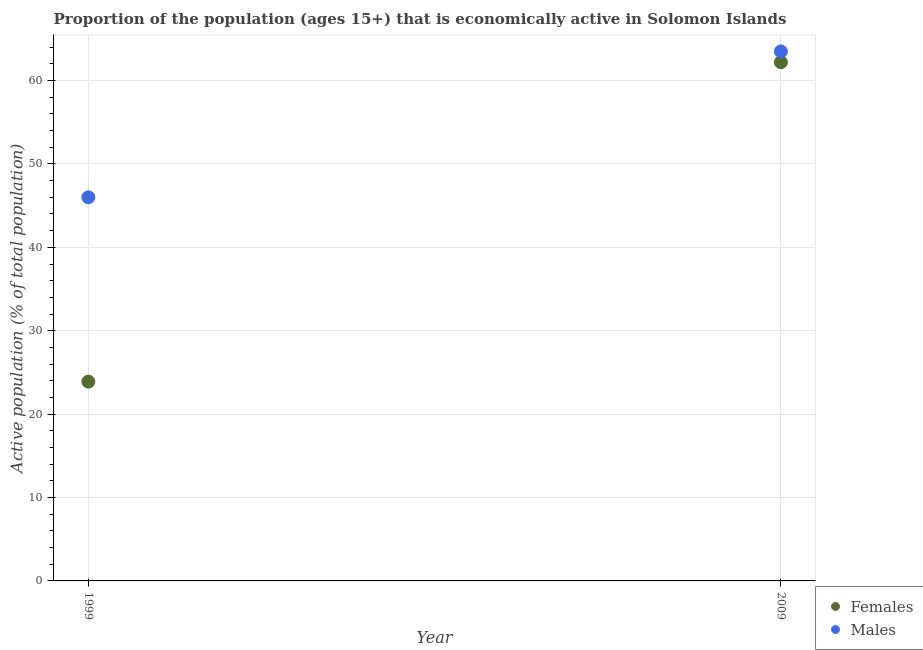What is the percentage of economically active female population in 1999?
Keep it short and to the point. 23.9. Across all years, what is the maximum percentage of economically active male population?
Your answer should be very brief. 63.5. In which year was the percentage of economically active female population maximum?
Make the answer very short. 2009. In which year was the percentage of economically active male population minimum?
Give a very brief answer. 1999. What is the total percentage of economically active male population in the graph?
Your response must be concise. 109.5. What is the difference between the percentage of economically active male population in 1999 and that in 2009?
Your answer should be compact. -17.5. What is the difference between the percentage of economically active female population in 1999 and the percentage of economically active male population in 2009?
Provide a short and direct response. -39.6. What is the average percentage of economically active male population per year?
Provide a succinct answer. 54.75. In the year 1999, what is the difference between the percentage of economically active male population and percentage of economically active female population?
Keep it short and to the point. 22.1. In how many years, is the percentage of economically active male population greater than 22 %?
Offer a terse response. 2. What is the ratio of the percentage of economically active male population in 1999 to that in 2009?
Offer a terse response. 0.72. Is the percentage of economically active male population in 1999 less than that in 2009?
Offer a terse response. Yes. In how many years, is the percentage of economically active male population greater than the average percentage of economically active male population taken over all years?
Your answer should be compact. 1. Does the percentage of economically active male population monotonically increase over the years?
Offer a terse response. Yes. Is the percentage of economically active female population strictly greater than the percentage of economically active male population over the years?
Provide a short and direct response. No. Is the percentage of economically active male population strictly less than the percentage of economically active female population over the years?
Ensure brevity in your answer.  No. Are the values on the major ticks of Y-axis written in scientific E-notation?
Give a very brief answer. No. Does the graph contain any zero values?
Your response must be concise. No. Does the graph contain grids?
Your answer should be very brief. Yes. How many legend labels are there?
Give a very brief answer. 2. How are the legend labels stacked?
Make the answer very short. Vertical. What is the title of the graph?
Your response must be concise. Proportion of the population (ages 15+) that is economically active in Solomon Islands. Does "Males" appear as one of the legend labels in the graph?
Keep it short and to the point. Yes. What is the label or title of the Y-axis?
Make the answer very short. Active population (% of total population). What is the Active population (% of total population) in Females in 1999?
Provide a short and direct response. 23.9. What is the Active population (% of total population) of Females in 2009?
Provide a short and direct response. 62.2. What is the Active population (% of total population) in Males in 2009?
Ensure brevity in your answer.  63.5. Across all years, what is the maximum Active population (% of total population) of Females?
Make the answer very short. 62.2. Across all years, what is the maximum Active population (% of total population) of Males?
Offer a terse response. 63.5. Across all years, what is the minimum Active population (% of total population) in Females?
Your answer should be compact. 23.9. Across all years, what is the minimum Active population (% of total population) in Males?
Offer a terse response. 46. What is the total Active population (% of total population) of Females in the graph?
Provide a short and direct response. 86.1. What is the total Active population (% of total population) in Males in the graph?
Offer a very short reply. 109.5. What is the difference between the Active population (% of total population) of Females in 1999 and that in 2009?
Your response must be concise. -38.3. What is the difference between the Active population (% of total population) in Males in 1999 and that in 2009?
Your answer should be compact. -17.5. What is the difference between the Active population (% of total population) in Females in 1999 and the Active population (% of total population) in Males in 2009?
Provide a short and direct response. -39.6. What is the average Active population (% of total population) in Females per year?
Ensure brevity in your answer.  43.05. What is the average Active population (% of total population) of Males per year?
Your answer should be very brief. 54.75. In the year 1999, what is the difference between the Active population (% of total population) of Females and Active population (% of total population) of Males?
Offer a terse response. -22.1. In the year 2009, what is the difference between the Active population (% of total population) in Females and Active population (% of total population) in Males?
Ensure brevity in your answer.  -1.3. What is the ratio of the Active population (% of total population) of Females in 1999 to that in 2009?
Your answer should be compact. 0.38. What is the ratio of the Active population (% of total population) of Males in 1999 to that in 2009?
Provide a short and direct response. 0.72. What is the difference between the highest and the second highest Active population (% of total population) in Females?
Provide a succinct answer. 38.3. What is the difference between the highest and the lowest Active population (% of total population) in Females?
Provide a succinct answer. 38.3. What is the difference between the highest and the lowest Active population (% of total population) of Males?
Keep it short and to the point. 17.5. 